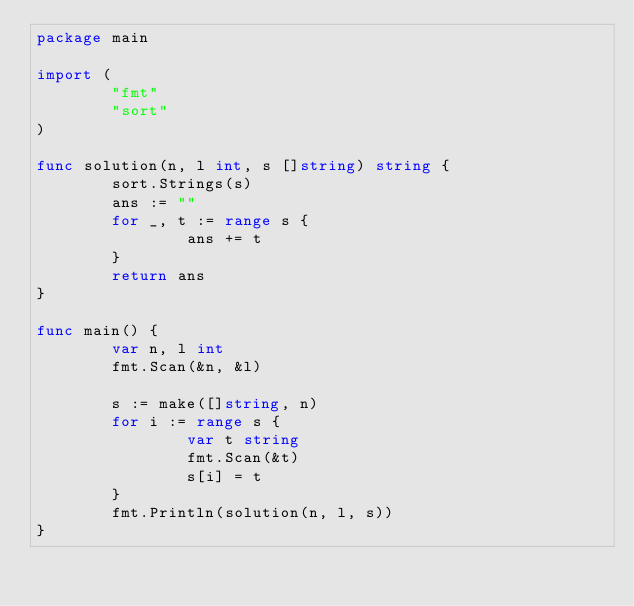Convert code to text. <code><loc_0><loc_0><loc_500><loc_500><_Go_>package main

import (
        "fmt"
        "sort"
)

func solution(n, l int, s []string) string {
        sort.Strings(s)
        ans := ""
        for _, t := range s {
                ans += t
        }
        return ans
}

func main() {
        var n, l int
        fmt.Scan(&n, &l)

        s := make([]string, n)
        for i := range s {
                var t string
                fmt.Scan(&t)
                s[i] = t
        }
        fmt.Println(solution(n, l, s))
}</code> 